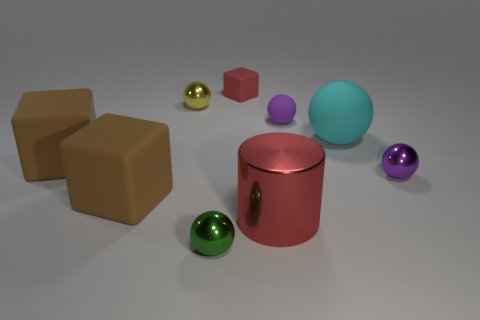Subtract all brown spheres. Subtract all green cylinders. How many spheres are left? 5 Add 1 big yellow cylinders. How many objects exist? 10 Subtract all balls. How many objects are left? 4 Add 8 large cyan rubber spheres. How many large cyan rubber spheres are left? 9 Add 2 rubber blocks. How many rubber blocks exist? 5 Subtract 1 red cubes. How many objects are left? 8 Subtract all small cyan things. Subtract all cylinders. How many objects are left? 8 